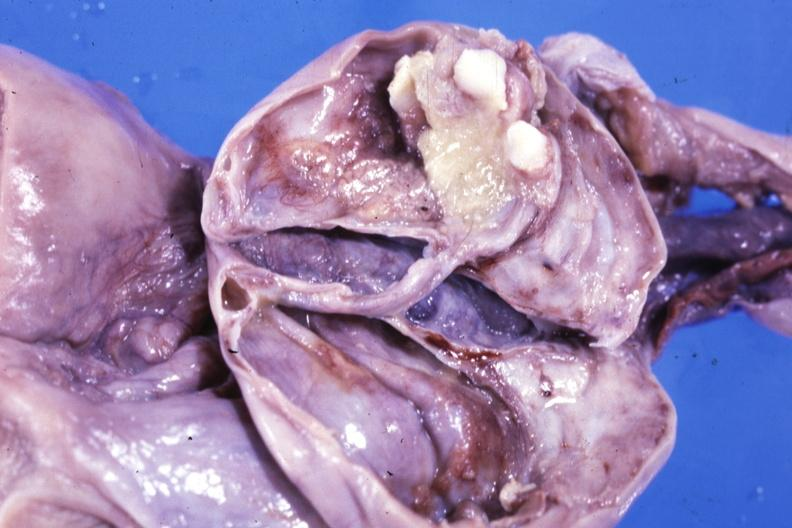how is fixed tissue opened ovarian cyst?
Answer the question using a single word or phrase. Two or three teeth 